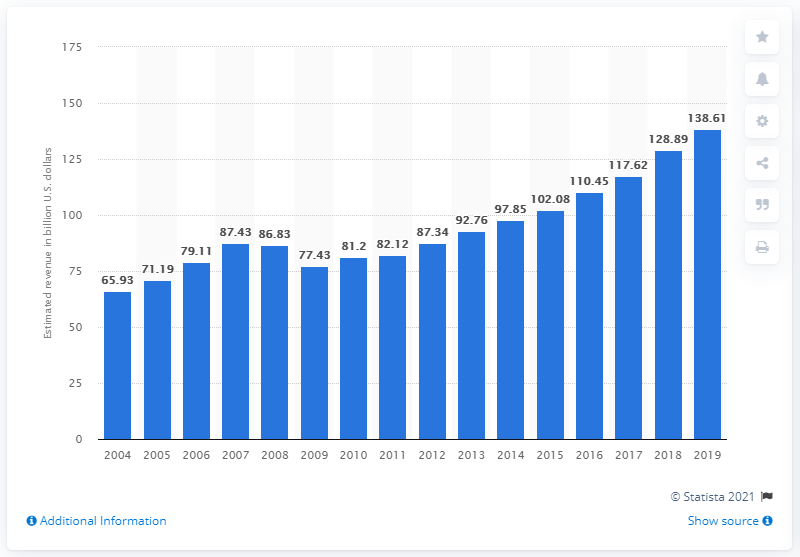List a handful of essential elements in this visual. The advertising and public relations industry is worth 138.61 dollars. 